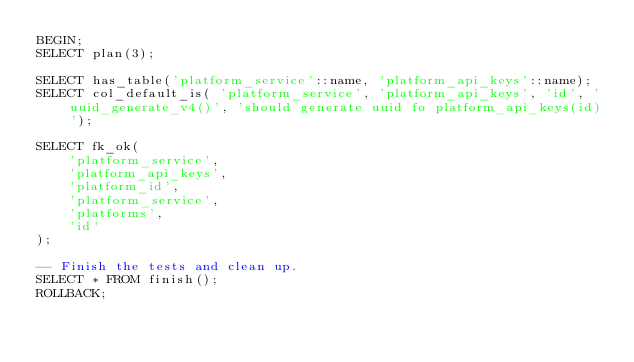Convert code to text. <code><loc_0><loc_0><loc_500><loc_500><_SQL_>BEGIN;
SELECT plan(3);

SELECT has_table('platform_service'::name, 'platform_api_keys'::name);
SELECT col_default_is( 'platform_service', 'platform_api_keys', 'id', 'uuid_generate_v4()', 'should generate uuid fo platform_api_keys(id)');

SELECT fk_ok( 
    'platform_service',
    'platform_api_keys',
    'platform_id',
    'platform_service',
    'platforms',
    'id'
);

-- Finish the tests and clean up.
SELECT * FROM finish();
ROLLBACK;
</code> 